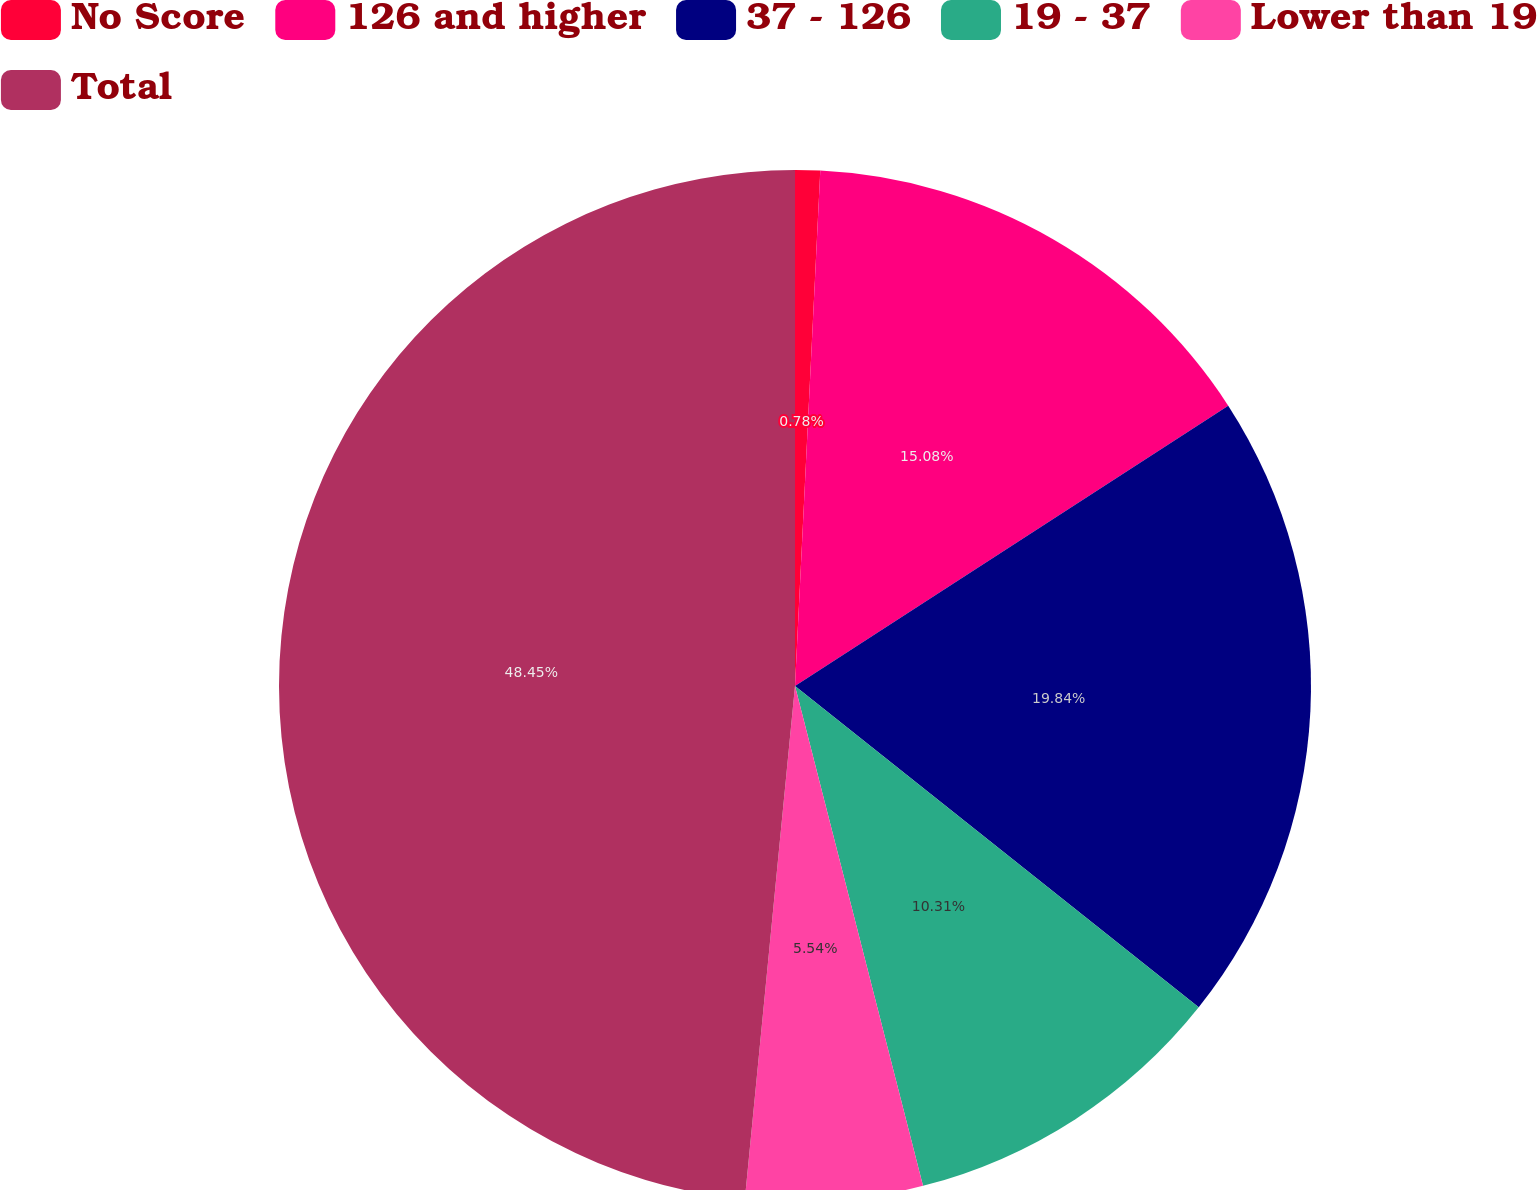<chart> <loc_0><loc_0><loc_500><loc_500><pie_chart><fcel>No Score<fcel>126 and higher<fcel>37 - 126<fcel>19 - 37<fcel>Lower than 19<fcel>Total<nl><fcel>0.78%<fcel>15.08%<fcel>19.84%<fcel>10.31%<fcel>5.54%<fcel>48.45%<nl></chart> 